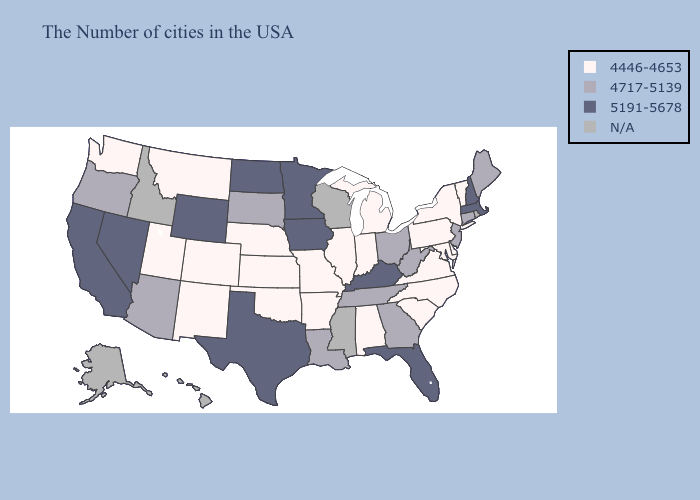Among the states that border Michigan , which have the highest value?
Answer briefly. Ohio. Does Wyoming have the lowest value in the USA?
Quick response, please. No. Name the states that have a value in the range 4717-5139?
Give a very brief answer. Maine, Connecticut, New Jersey, West Virginia, Ohio, Georgia, Tennessee, Louisiana, South Dakota, Arizona, Oregon. What is the value of Alabama?
Concise answer only. 4446-4653. What is the value of Massachusetts?
Concise answer only. 5191-5678. Name the states that have a value in the range 4717-5139?
Write a very short answer. Maine, Connecticut, New Jersey, West Virginia, Ohio, Georgia, Tennessee, Louisiana, South Dakota, Arizona, Oregon. What is the value of Mississippi?
Give a very brief answer. N/A. What is the highest value in the USA?
Keep it brief. 5191-5678. Which states have the highest value in the USA?
Concise answer only. Massachusetts, New Hampshire, Florida, Kentucky, Minnesota, Iowa, Texas, North Dakota, Wyoming, Nevada, California. What is the value of Oklahoma?
Keep it brief. 4446-4653. Name the states that have a value in the range 5191-5678?
Write a very short answer. Massachusetts, New Hampshire, Florida, Kentucky, Minnesota, Iowa, Texas, North Dakota, Wyoming, Nevada, California. What is the value of New Hampshire?
Write a very short answer. 5191-5678. What is the value of Louisiana?
Short answer required. 4717-5139. 